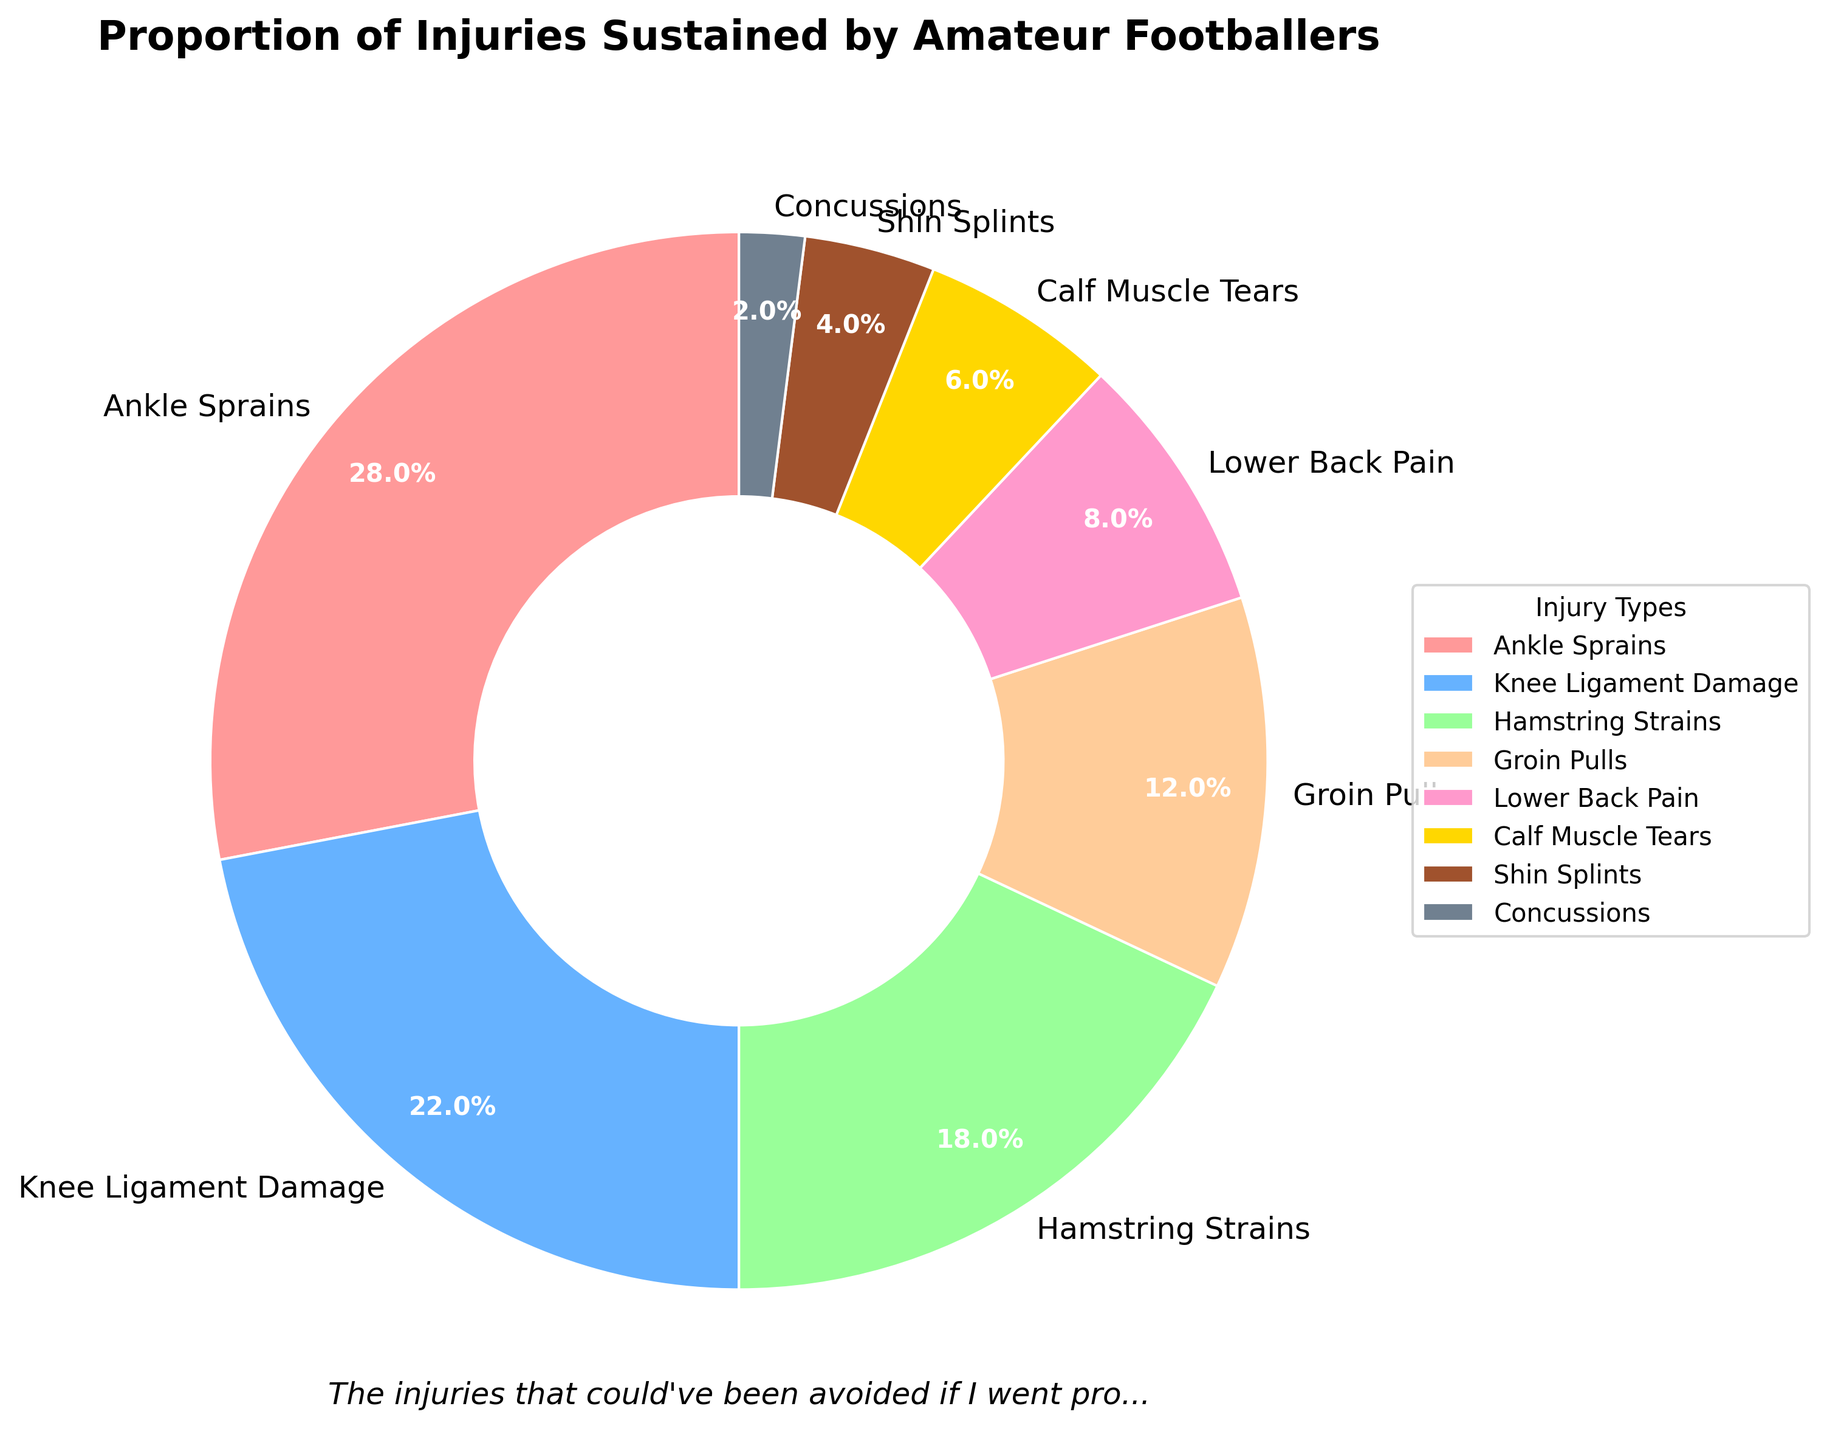What injury type accounts for the largest proportion of injuries? The largest wedge on the pie chart represents "Ankle Sprains", which can be identified visually as taking up the most space.
Answer: Ankle Sprains What is the combined percentage of Knee Ligament Damage and Hamstring Strains? Knee Ligament Damage accounts for 22% and Hamstring Strains account for 18%, so their combined percentage is 22% + 18%.
Answer: 40% Which injury type has the smallest proportion? By looking at the smallest wedge on the pie chart, we can see that "Concussions" take up the least amount of space.
Answer: Concussions Are Groin Pulls more or less common than Lower Back Pain? Observing the pie chart, we see that Groin Pulls account for 12% while Lower Back Pain takes up 8%. Thus, Groin Pulls are more common.
Answer: More What percentage of injuries are represented by Calf Muscle Tears and Shin Splints combined? Calf Muscle Tears account for 6% and Shin Splints account for 4%, adding these together gives us 6% + 4%.
Answer: 10% How do Hamstring Strains and Groin Pulls compare in terms of percentage? Hamstring Strains account for 18% while Groin Pulls account for 12%, indicating Hamstring Strains are more common.
Answer: Hamstring Strains are more common What two injury types together make up over half of the injuries? Ankle Sprains (28%) and Knee Ligament Damage (22%) combined give 28% + 22% = 50%, making them together cover exactly half. If counted, some can include Hamstring Strains (total 68%).
Answer: Ankle Sprains and Knee Ligament Damage Which injury type is highlighted in pink? In the custom color scheme specified, the injury type labeled "Ankle Sprains" is highlighted in pink.
Answer: Ankle Sprains What is the proportion ratio between Ankle Sprains and Concussions? Ankle Sprains are 28% and Concussions are 2%. The ratio is 28/2, which simplifies to 14:1.
Answer: 14:1 If we grouped muscle-related injuries (Hamstring Strains, Groin Pulls, Calf Muscle Tears) together, what would be their total percentage? Hamstring Strains are 18%, Groin Pulls are 12%, and Calf Muscle Tears are 6%. Adding these, 18% + 12% + 6% = 36%.
Answer: 36% 